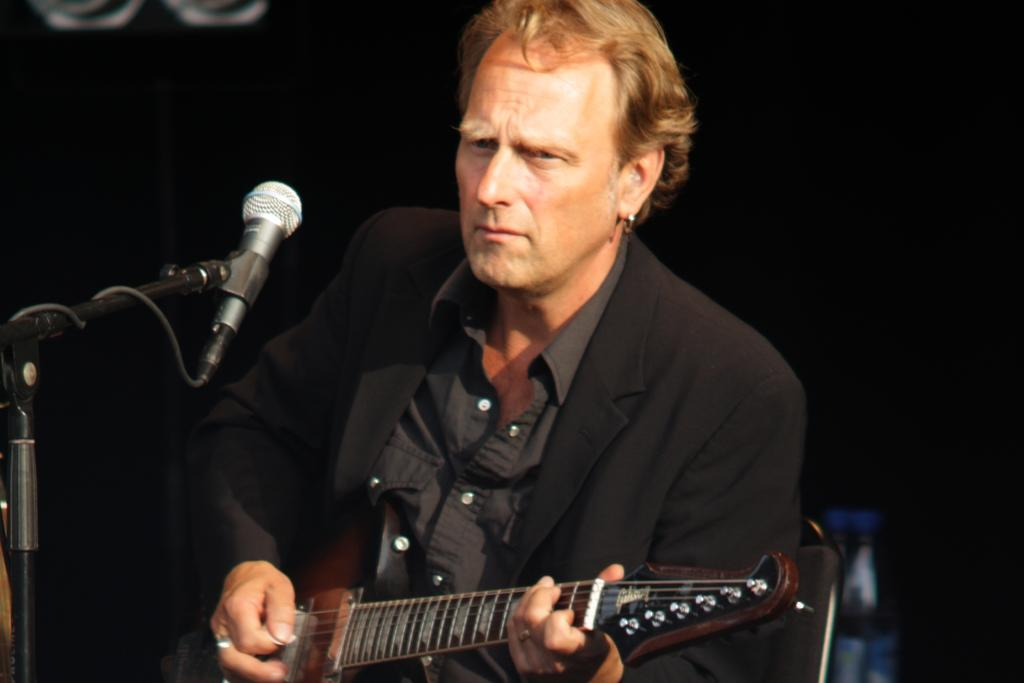Who is the main subject in the image? There is a man in the image. What is the man doing in the image? The man is sitting on a chair and holding a guitar in his hand. What object is in front of the man? There is a microphone with a stand in front of the man. What type of beast can be seen guarding the mailbox in the image? There is no beast or mailbox present in the image. What bone is the man holding in his hand instead of a guitar? The man is not holding a bone in his hand; he is holding a guitar. 